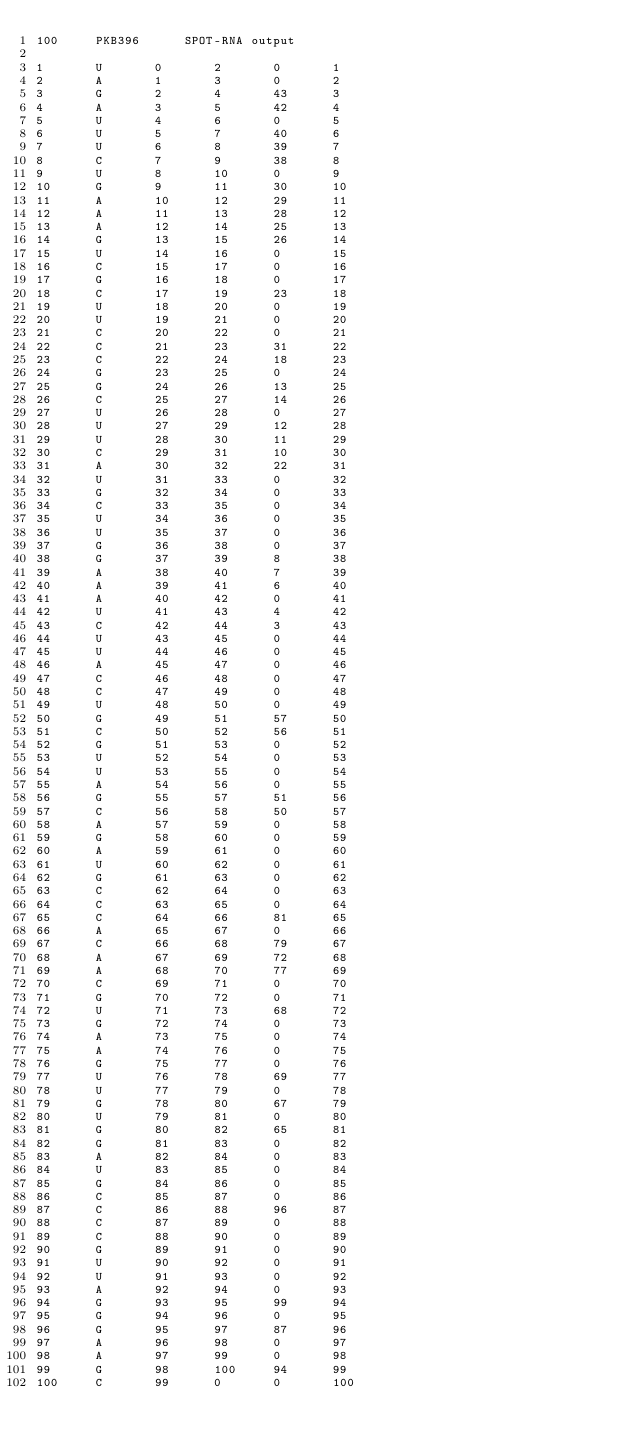<code> <loc_0><loc_0><loc_500><loc_500><_XML_>100		PKB396		SPOT-RNA output

1		U		0		2		0		1
2		A		1		3		0		2
3		G		2		4		43		3
4		A		3		5		42		4
5		U		4		6		0		5
6		U		5		7		40		6
7		U		6		8		39		7
8		C		7		9		38		8
9		U		8		10		0		9
10		G		9		11		30		10
11		A		10		12		29		11
12		A		11		13		28		12
13		A		12		14		25		13
14		G		13		15		26		14
15		U		14		16		0		15
16		C		15		17		0		16
17		G		16		18		0		17
18		C		17		19		23		18
19		U		18		20		0		19
20		U		19		21		0		20
21		C		20		22		0		21
22		C		21		23		31		22
23		C		22		24		18		23
24		G		23		25		0		24
25		G		24		26		13		25
26		C		25		27		14		26
27		U		26		28		0		27
28		U		27		29		12		28
29		U		28		30		11		29
30		C		29		31		10		30
31		A		30		32		22		31
32		U		31		33		0		32
33		G		32		34		0		33
34		C		33		35		0		34
35		U		34		36		0		35
36		U		35		37		0		36
37		G		36		38		0		37
38		G		37		39		8		38
39		A		38		40		7		39
40		A		39		41		6		40
41		A		40		42		0		41
42		U		41		43		4		42
43		C		42		44		3		43
44		U		43		45		0		44
45		U		44		46		0		45
46		A		45		47		0		46
47		C		46		48		0		47
48		C		47		49		0		48
49		U		48		50		0		49
50		G		49		51		57		50
51		C		50		52		56		51
52		G		51		53		0		52
53		U		52		54		0		53
54		U		53		55		0		54
55		A		54		56		0		55
56		G		55		57		51		56
57		C		56		58		50		57
58		A		57		59		0		58
59		G		58		60		0		59
60		A		59		61		0		60
61		U		60		62		0		61
62		G		61		63		0		62
63		C		62		64		0		63
64		C		63		65		0		64
65		C		64		66		81		65
66		A		65		67		0		66
67		C		66		68		79		67
68		A		67		69		72		68
69		A		68		70		77		69
70		C		69		71		0		70
71		G		70		72		0		71
72		U		71		73		68		72
73		G		72		74		0		73
74		A		73		75		0		74
75		A		74		76		0		75
76		G		75		77		0		76
77		U		76		78		69		77
78		U		77		79		0		78
79		G		78		80		67		79
80		U		79		81		0		80
81		G		80		82		65		81
82		G		81		83		0		82
83		A		82		84		0		83
84		U		83		85		0		84
85		G		84		86		0		85
86		C		85		87		0		86
87		C		86		88		96		87
88		C		87		89		0		88
89		C		88		90		0		89
90		G		89		91		0		90
91		U		90		92		0		91
92		U		91		93		0		92
93		A		92		94		0		93
94		G		93		95		99		94
95		G		94		96		0		95
96		G		95		97		87		96
97		A		96		98		0		97
98		A		97		99		0		98
99		G		98		100		94		99
100		C		99		0		0		100
</code> 